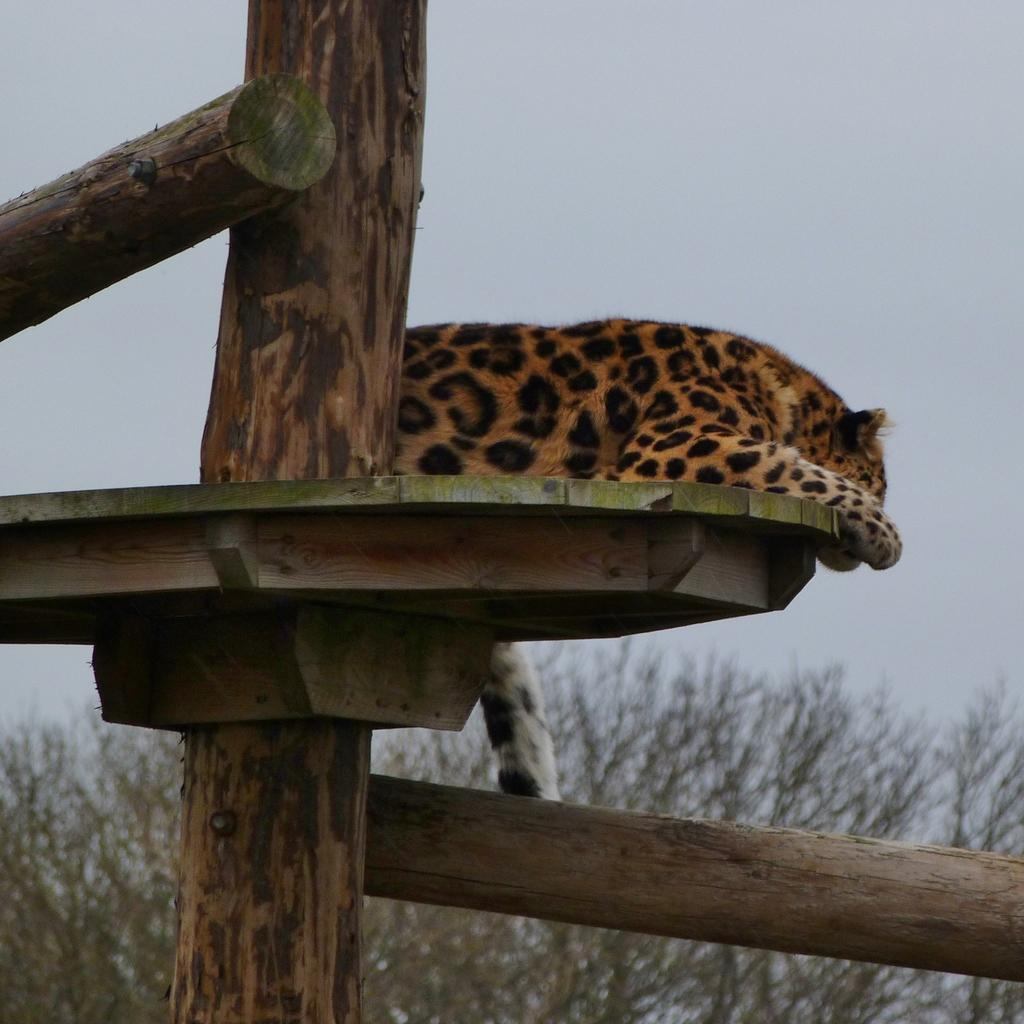What can be seen in the background of the image? There is a sky and trees visible in the background of the image. What type of structures are present in the image? There are wooden poles and a wooden platform in the image. What animal is on the wooden platform? A leopard is present on the wooden platform. How many feet are visible on the table in the image? There is no table present in the image, so no feet can be seen on a table. 